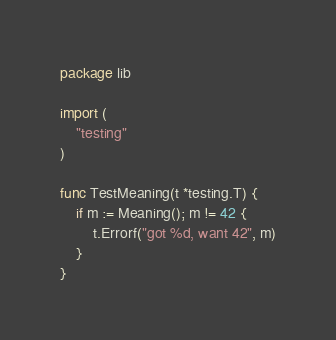<code> <loc_0><loc_0><loc_500><loc_500><_Go_>package lib

import (
	"testing"
)

func TestMeaning(t *testing.T) {
	if m := Meaning(); m != 42 {
		t.Errorf("got %d, want 42", m)
	}
}
</code> 